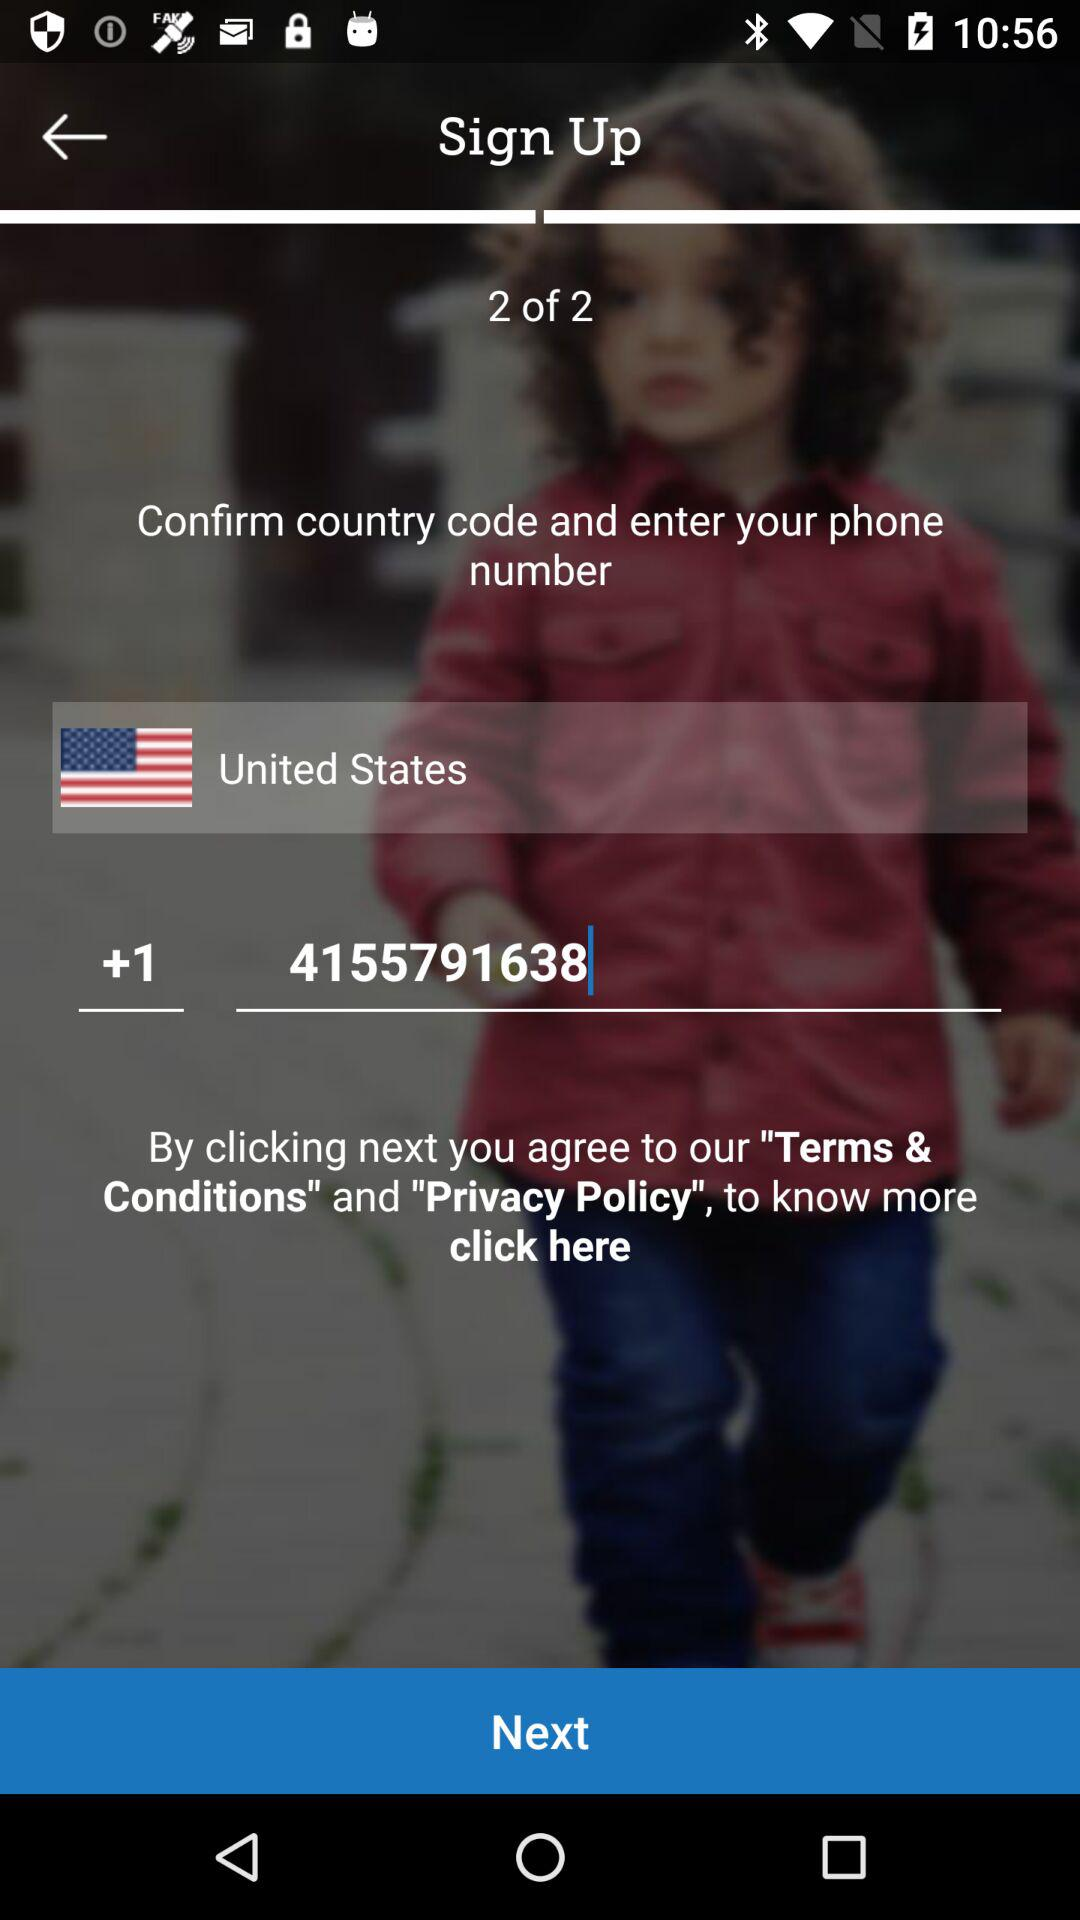What is the phone number? The phone number is +1 4155791638. 